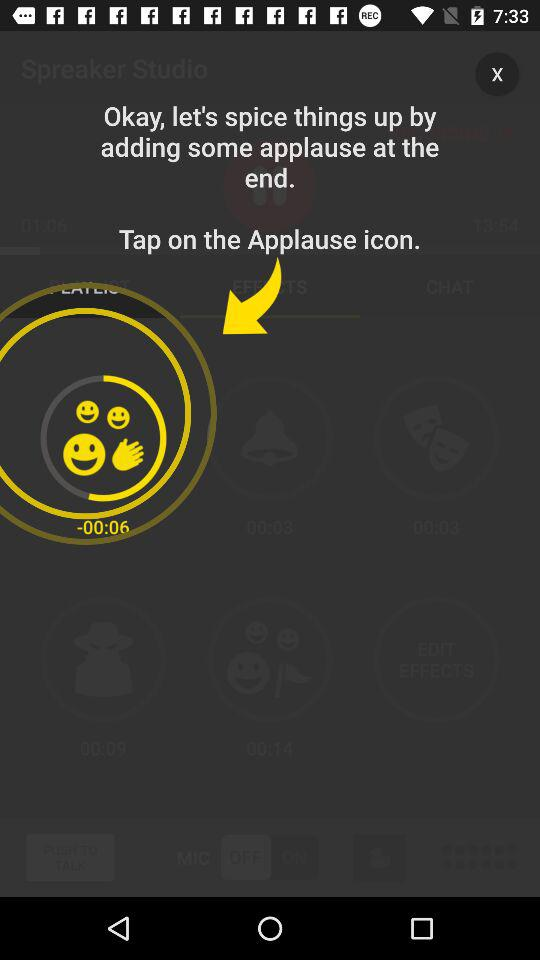What is the duration of the recording in minutes? The duration of the recording is 15 minutes. 